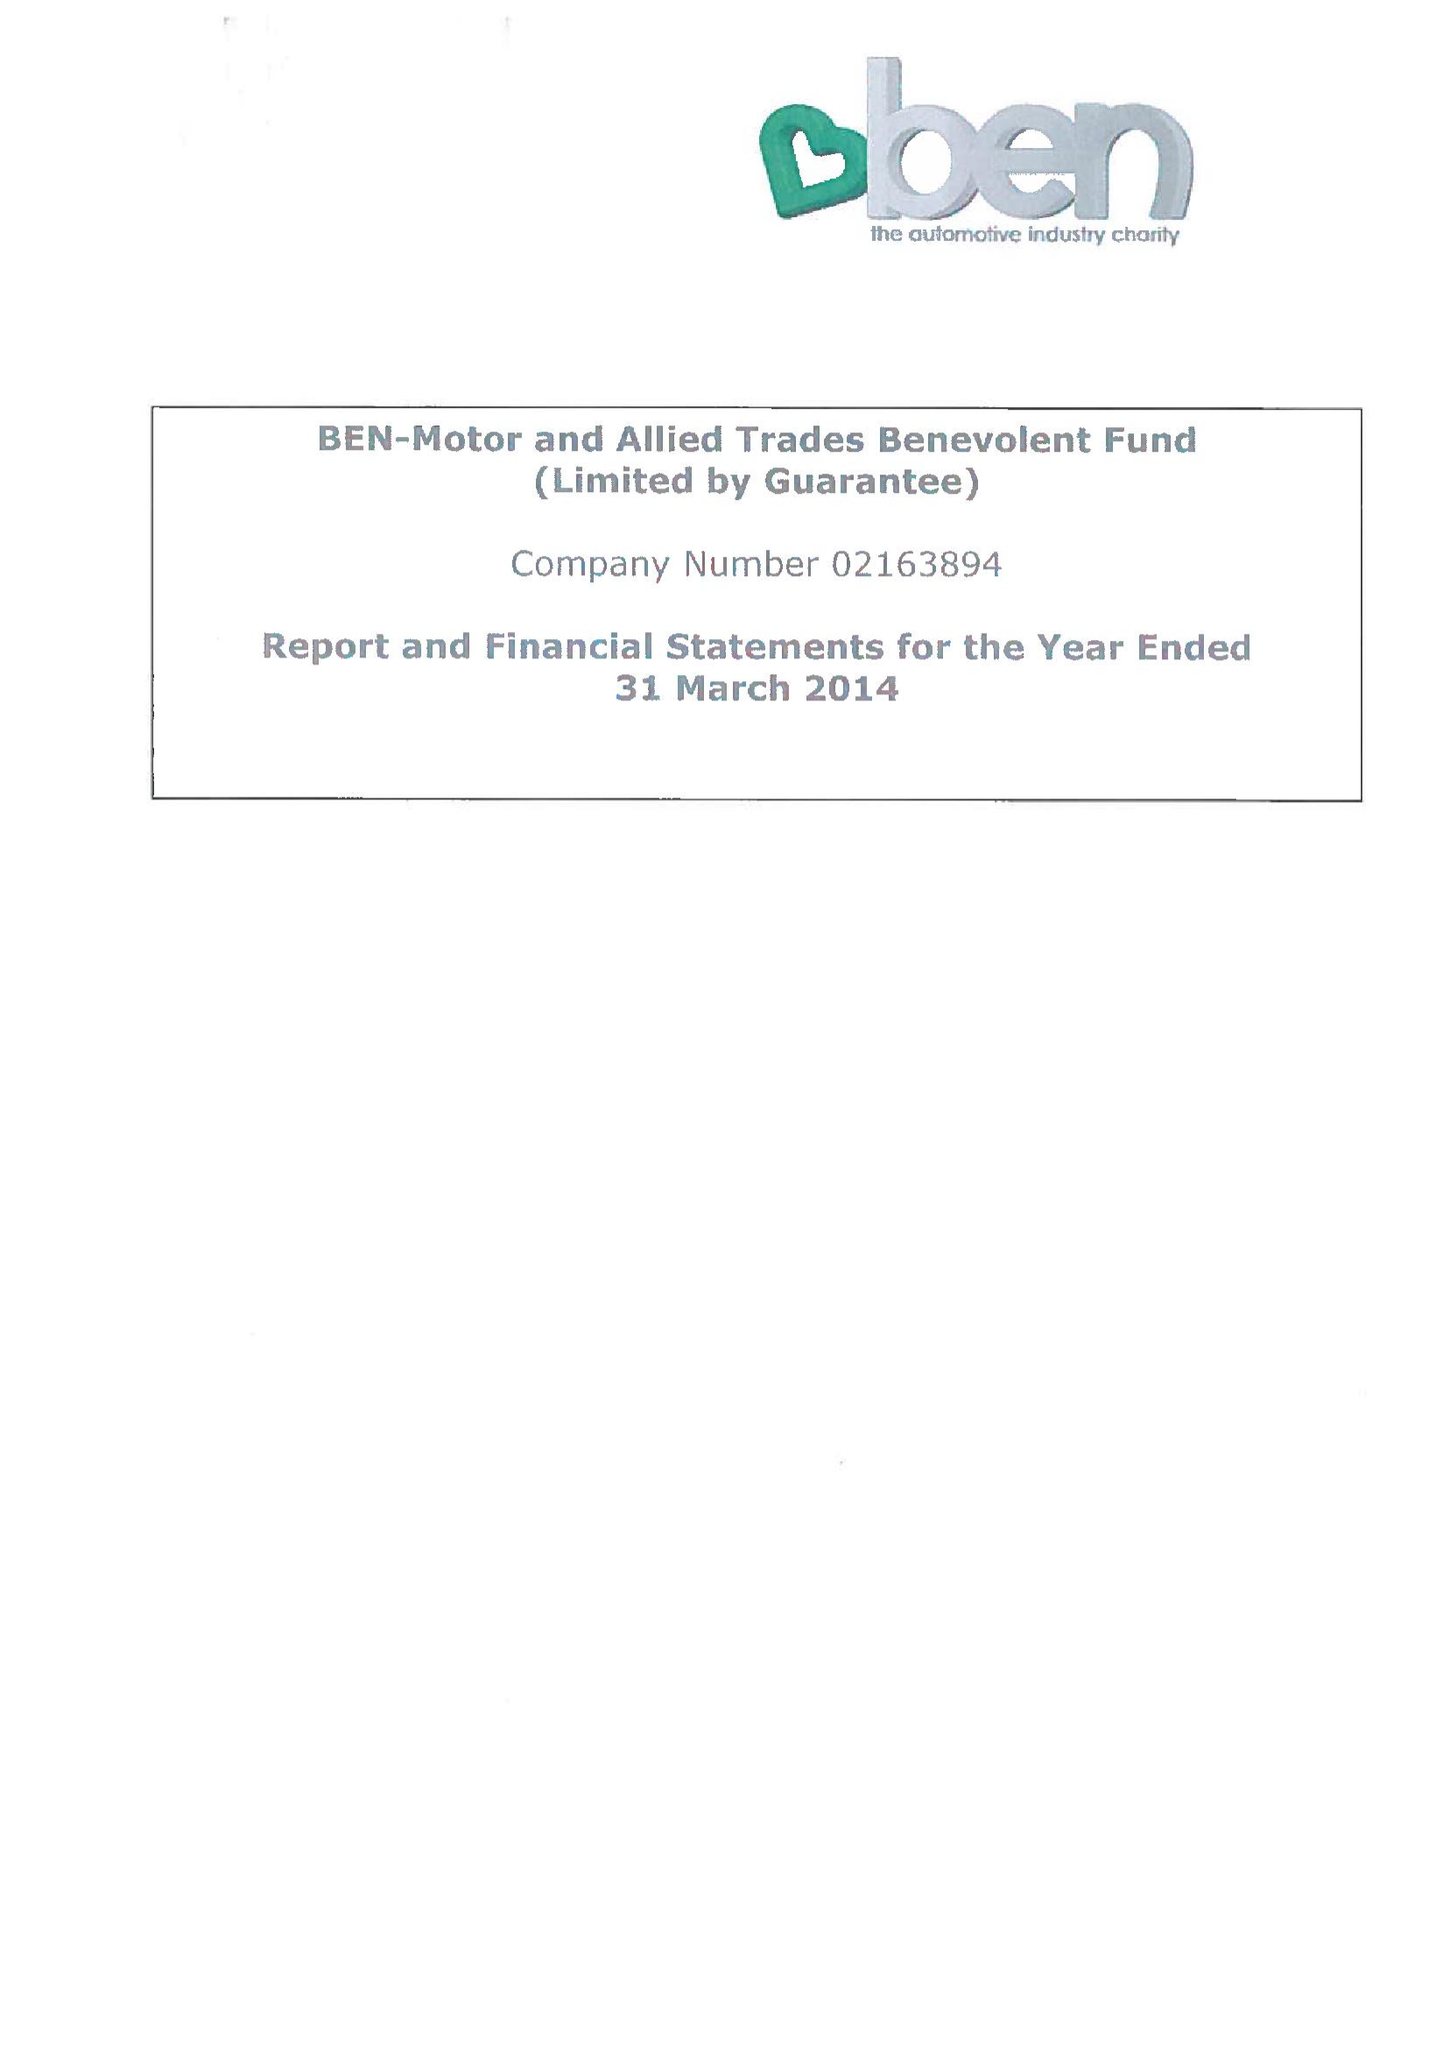What is the value for the charity_number?
Answer the question using a single word or phrase. 297877 